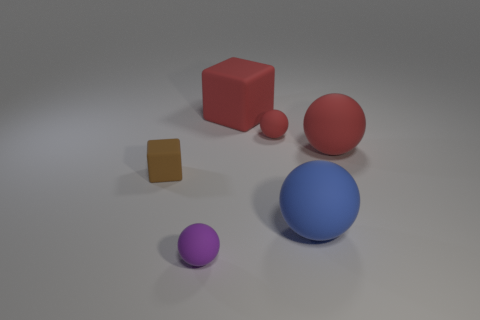Add 1 large cyan rubber cubes. How many objects exist? 7 Subtract 1 blocks. How many blocks are left? 1 Add 1 large spheres. How many large spheres are left? 3 Add 6 small green metal cylinders. How many small green metal cylinders exist? 6 Subtract all blue spheres. How many spheres are left? 3 Subtract all blue matte spheres. How many spheres are left? 3 Subtract 0 yellow spheres. How many objects are left? 6 Subtract all balls. How many objects are left? 2 Subtract all red blocks. Subtract all blue balls. How many blocks are left? 1 Subtract all yellow blocks. How many purple spheres are left? 1 